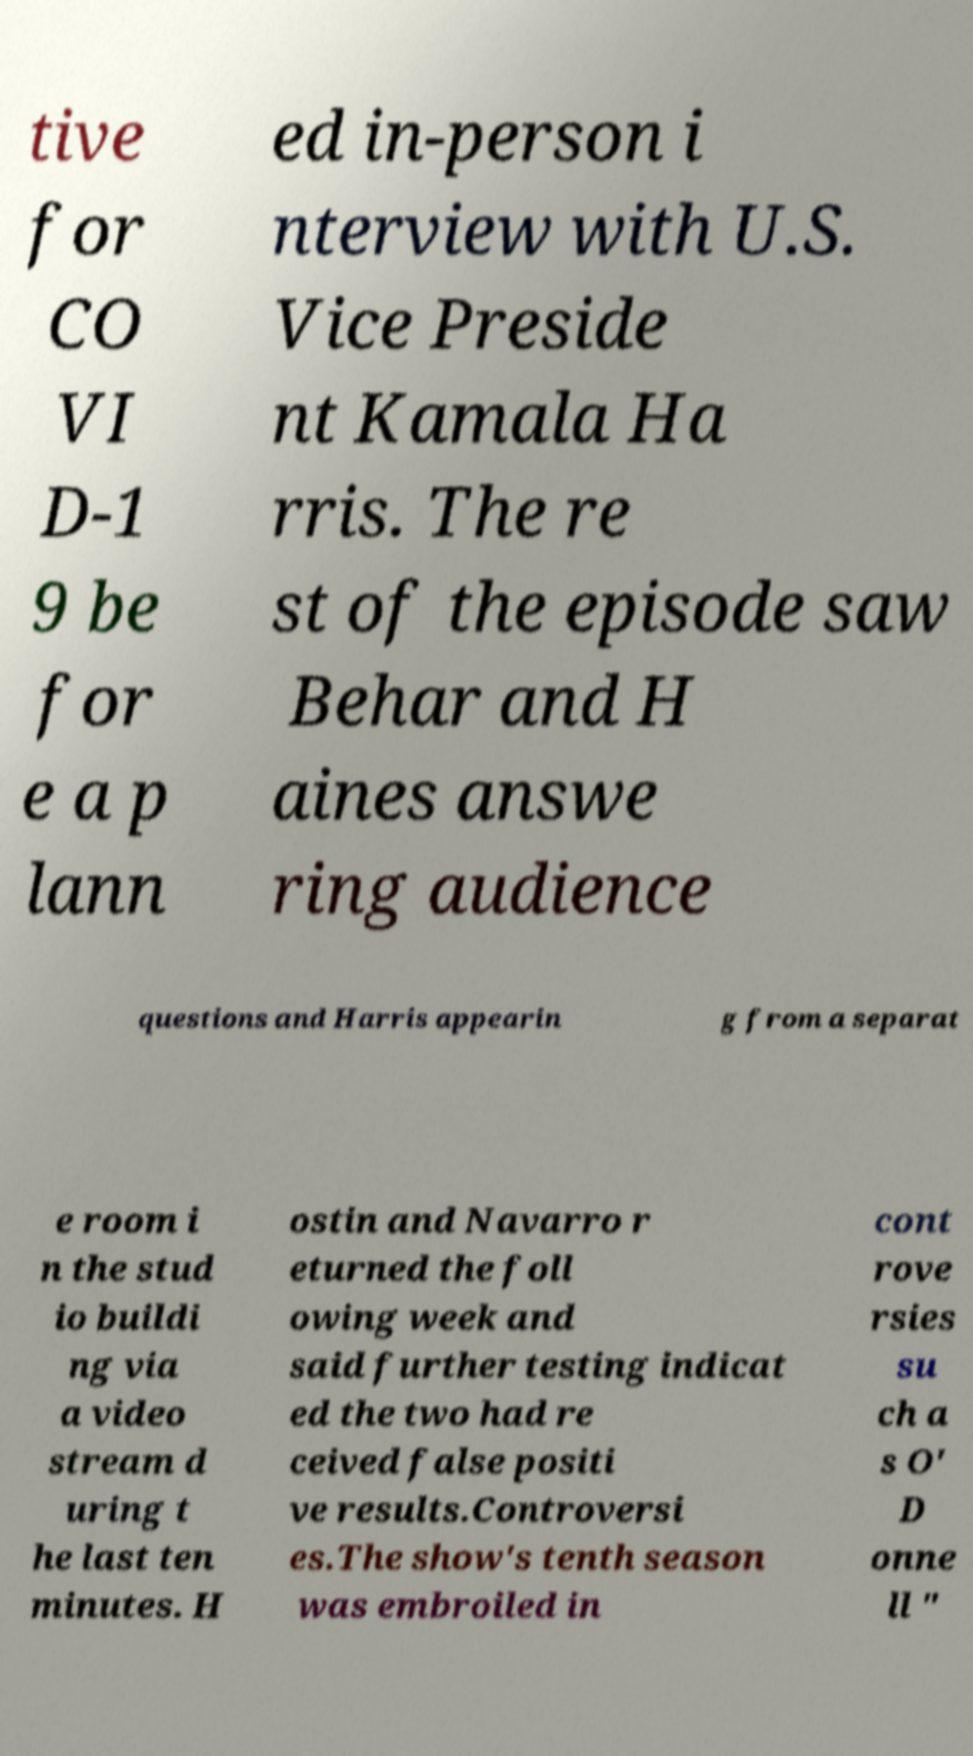For documentation purposes, I need the text within this image transcribed. Could you provide that? tive for CO VI D-1 9 be for e a p lann ed in-person i nterview with U.S. Vice Preside nt Kamala Ha rris. The re st of the episode saw Behar and H aines answe ring audience questions and Harris appearin g from a separat e room i n the stud io buildi ng via a video stream d uring t he last ten minutes. H ostin and Navarro r eturned the foll owing week and said further testing indicat ed the two had re ceived false positi ve results.Controversi es.The show's tenth season was embroiled in cont rove rsies su ch a s O' D onne ll " 